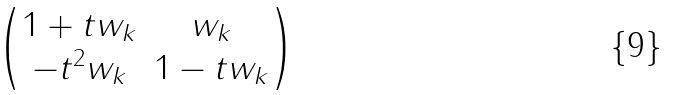Convert formula to latex. <formula><loc_0><loc_0><loc_500><loc_500>\begin{pmatrix} 1 + t w _ { k } & w _ { k } \\ - t ^ { 2 } w _ { k } & 1 - t w _ { k } \end{pmatrix}</formula> 